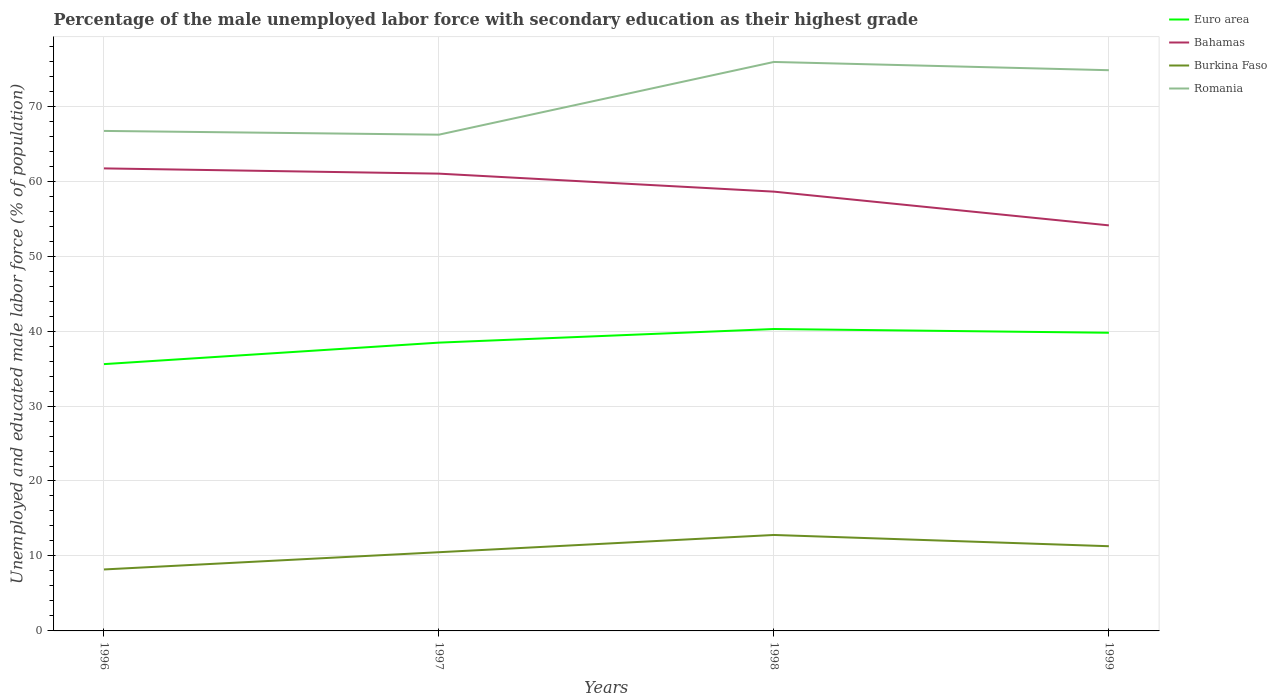Does the line corresponding to Bahamas intersect with the line corresponding to Burkina Faso?
Your answer should be very brief. No. Is the number of lines equal to the number of legend labels?
Your response must be concise. Yes. Across all years, what is the maximum percentage of the unemployed male labor force with secondary education in Romania?
Ensure brevity in your answer.  66.2. What is the total percentage of the unemployed male labor force with secondary education in Euro area in the graph?
Make the answer very short. -4.68. What is the difference between the highest and the second highest percentage of the unemployed male labor force with secondary education in Burkina Faso?
Your response must be concise. 4.6. How many years are there in the graph?
Give a very brief answer. 4. Are the values on the major ticks of Y-axis written in scientific E-notation?
Your response must be concise. No. Does the graph contain any zero values?
Provide a succinct answer. No. What is the title of the graph?
Give a very brief answer. Percentage of the male unemployed labor force with secondary education as their highest grade. Does "Indonesia" appear as one of the legend labels in the graph?
Give a very brief answer. No. What is the label or title of the X-axis?
Your answer should be very brief. Years. What is the label or title of the Y-axis?
Provide a succinct answer. Unemployed and educated male labor force (% of population). What is the Unemployed and educated male labor force (% of population) in Euro area in 1996?
Make the answer very short. 35.59. What is the Unemployed and educated male labor force (% of population) in Bahamas in 1996?
Keep it short and to the point. 61.7. What is the Unemployed and educated male labor force (% of population) in Burkina Faso in 1996?
Provide a short and direct response. 8.2. What is the Unemployed and educated male labor force (% of population) in Romania in 1996?
Your answer should be very brief. 66.7. What is the Unemployed and educated male labor force (% of population) in Euro area in 1997?
Provide a short and direct response. 38.46. What is the Unemployed and educated male labor force (% of population) in Bahamas in 1997?
Offer a very short reply. 61. What is the Unemployed and educated male labor force (% of population) in Burkina Faso in 1997?
Keep it short and to the point. 10.5. What is the Unemployed and educated male labor force (% of population) in Romania in 1997?
Offer a very short reply. 66.2. What is the Unemployed and educated male labor force (% of population) in Euro area in 1998?
Your answer should be very brief. 40.27. What is the Unemployed and educated male labor force (% of population) in Bahamas in 1998?
Provide a succinct answer. 58.6. What is the Unemployed and educated male labor force (% of population) in Burkina Faso in 1998?
Give a very brief answer. 12.8. What is the Unemployed and educated male labor force (% of population) of Romania in 1998?
Give a very brief answer. 75.9. What is the Unemployed and educated male labor force (% of population) of Euro area in 1999?
Make the answer very short. 39.78. What is the Unemployed and educated male labor force (% of population) of Bahamas in 1999?
Your response must be concise. 54.1. What is the Unemployed and educated male labor force (% of population) of Burkina Faso in 1999?
Keep it short and to the point. 11.3. What is the Unemployed and educated male labor force (% of population) in Romania in 1999?
Provide a succinct answer. 74.8. Across all years, what is the maximum Unemployed and educated male labor force (% of population) of Euro area?
Provide a short and direct response. 40.27. Across all years, what is the maximum Unemployed and educated male labor force (% of population) in Bahamas?
Give a very brief answer. 61.7. Across all years, what is the maximum Unemployed and educated male labor force (% of population) of Burkina Faso?
Provide a short and direct response. 12.8. Across all years, what is the maximum Unemployed and educated male labor force (% of population) of Romania?
Ensure brevity in your answer.  75.9. Across all years, what is the minimum Unemployed and educated male labor force (% of population) of Euro area?
Keep it short and to the point. 35.59. Across all years, what is the minimum Unemployed and educated male labor force (% of population) of Bahamas?
Provide a short and direct response. 54.1. Across all years, what is the minimum Unemployed and educated male labor force (% of population) in Burkina Faso?
Keep it short and to the point. 8.2. Across all years, what is the minimum Unemployed and educated male labor force (% of population) of Romania?
Keep it short and to the point. 66.2. What is the total Unemployed and educated male labor force (% of population) in Euro area in the graph?
Your answer should be compact. 154.1. What is the total Unemployed and educated male labor force (% of population) in Bahamas in the graph?
Offer a terse response. 235.4. What is the total Unemployed and educated male labor force (% of population) in Burkina Faso in the graph?
Offer a terse response. 42.8. What is the total Unemployed and educated male labor force (% of population) of Romania in the graph?
Offer a terse response. 283.6. What is the difference between the Unemployed and educated male labor force (% of population) of Euro area in 1996 and that in 1997?
Ensure brevity in your answer.  -2.87. What is the difference between the Unemployed and educated male labor force (% of population) of Bahamas in 1996 and that in 1997?
Offer a terse response. 0.7. What is the difference between the Unemployed and educated male labor force (% of population) in Romania in 1996 and that in 1997?
Your answer should be compact. 0.5. What is the difference between the Unemployed and educated male labor force (% of population) in Euro area in 1996 and that in 1998?
Keep it short and to the point. -4.68. What is the difference between the Unemployed and educated male labor force (% of population) in Bahamas in 1996 and that in 1998?
Your answer should be compact. 3.1. What is the difference between the Unemployed and educated male labor force (% of population) in Romania in 1996 and that in 1998?
Your answer should be very brief. -9.2. What is the difference between the Unemployed and educated male labor force (% of population) of Euro area in 1996 and that in 1999?
Ensure brevity in your answer.  -4.19. What is the difference between the Unemployed and educated male labor force (% of population) of Euro area in 1997 and that in 1998?
Your answer should be compact. -1.81. What is the difference between the Unemployed and educated male labor force (% of population) of Bahamas in 1997 and that in 1998?
Your response must be concise. 2.4. What is the difference between the Unemployed and educated male labor force (% of population) in Burkina Faso in 1997 and that in 1998?
Your response must be concise. -2.3. What is the difference between the Unemployed and educated male labor force (% of population) in Euro area in 1997 and that in 1999?
Give a very brief answer. -1.32. What is the difference between the Unemployed and educated male labor force (% of population) of Bahamas in 1997 and that in 1999?
Make the answer very short. 6.9. What is the difference between the Unemployed and educated male labor force (% of population) in Burkina Faso in 1997 and that in 1999?
Your response must be concise. -0.8. What is the difference between the Unemployed and educated male labor force (% of population) of Romania in 1997 and that in 1999?
Make the answer very short. -8.6. What is the difference between the Unemployed and educated male labor force (% of population) in Euro area in 1998 and that in 1999?
Offer a very short reply. 0.5. What is the difference between the Unemployed and educated male labor force (% of population) of Euro area in 1996 and the Unemployed and educated male labor force (% of population) of Bahamas in 1997?
Offer a terse response. -25.41. What is the difference between the Unemployed and educated male labor force (% of population) of Euro area in 1996 and the Unemployed and educated male labor force (% of population) of Burkina Faso in 1997?
Offer a very short reply. 25.09. What is the difference between the Unemployed and educated male labor force (% of population) of Euro area in 1996 and the Unemployed and educated male labor force (% of population) of Romania in 1997?
Offer a very short reply. -30.61. What is the difference between the Unemployed and educated male labor force (% of population) of Bahamas in 1996 and the Unemployed and educated male labor force (% of population) of Burkina Faso in 1997?
Provide a short and direct response. 51.2. What is the difference between the Unemployed and educated male labor force (% of population) of Burkina Faso in 1996 and the Unemployed and educated male labor force (% of population) of Romania in 1997?
Ensure brevity in your answer.  -58. What is the difference between the Unemployed and educated male labor force (% of population) in Euro area in 1996 and the Unemployed and educated male labor force (% of population) in Bahamas in 1998?
Your answer should be very brief. -23.01. What is the difference between the Unemployed and educated male labor force (% of population) in Euro area in 1996 and the Unemployed and educated male labor force (% of population) in Burkina Faso in 1998?
Your answer should be compact. 22.79. What is the difference between the Unemployed and educated male labor force (% of population) of Euro area in 1996 and the Unemployed and educated male labor force (% of population) of Romania in 1998?
Your answer should be compact. -40.31. What is the difference between the Unemployed and educated male labor force (% of population) of Bahamas in 1996 and the Unemployed and educated male labor force (% of population) of Burkina Faso in 1998?
Your answer should be compact. 48.9. What is the difference between the Unemployed and educated male labor force (% of population) of Burkina Faso in 1996 and the Unemployed and educated male labor force (% of population) of Romania in 1998?
Ensure brevity in your answer.  -67.7. What is the difference between the Unemployed and educated male labor force (% of population) in Euro area in 1996 and the Unemployed and educated male labor force (% of population) in Bahamas in 1999?
Your response must be concise. -18.51. What is the difference between the Unemployed and educated male labor force (% of population) in Euro area in 1996 and the Unemployed and educated male labor force (% of population) in Burkina Faso in 1999?
Keep it short and to the point. 24.29. What is the difference between the Unemployed and educated male labor force (% of population) of Euro area in 1996 and the Unemployed and educated male labor force (% of population) of Romania in 1999?
Your response must be concise. -39.21. What is the difference between the Unemployed and educated male labor force (% of population) of Bahamas in 1996 and the Unemployed and educated male labor force (% of population) of Burkina Faso in 1999?
Offer a terse response. 50.4. What is the difference between the Unemployed and educated male labor force (% of population) of Bahamas in 1996 and the Unemployed and educated male labor force (% of population) of Romania in 1999?
Offer a very short reply. -13.1. What is the difference between the Unemployed and educated male labor force (% of population) in Burkina Faso in 1996 and the Unemployed and educated male labor force (% of population) in Romania in 1999?
Keep it short and to the point. -66.6. What is the difference between the Unemployed and educated male labor force (% of population) of Euro area in 1997 and the Unemployed and educated male labor force (% of population) of Bahamas in 1998?
Provide a succinct answer. -20.14. What is the difference between the Unemployed and educated male labor force (% of population) of Euro area in 1997 and the Unemployed and educated male labor force (% of population) of Burkina Faso in 1998?
Make the answer very short. 25.66. What is the difference between the Unemployed and educated male labor force (% of population) in Euro area in 1997 and the Unemployed and educated male labor force (% of population) in Romania in 1998?
Ensure brevity in your answer.  -37.44. What is the difference between the Unemployed and educated male labor force (% of population) of Bahamas in 1997 and the Unemployed and educated male labor force (% of population) of Burkina Faso in 1998?
Provide a short and direct response. 48.2. What is the difference between the Unemployed and educated male labor force (% of population) in Bahamas in 1997 and the Unemployed and educated male labor force (% of population) in Romania in 1998?
Make the answer very short. -14.9. What is the difference between the Unemployed and educated male labor force (% of population) in Burkina Faso in 1997 and the Unemployed and educated male labor force (% of population) in Romania in 1998?
Your answer should be very brief. -65.4. What is the difference between the Unemployed and educated male labor force (% of population) of Euro area in 1997 and the Unemployed and educated male labor force (% of population) of Bahamas in 1999?
Provide a short and direct response. -15.64. What is the difference between the Unemployed and educated male labor force (% of population) in Euro area in 1997 and the Unemployed and educated male labor force (% of population) in Burkina Faso in 1999?
Keep it short and to the point. 27.16. What is the difference between the Unemployed and educated male labor force (% of population) in Euro area in 1997 and the Unemployed and educated male labor force (% of population) in Romania in 1999?
Your answer should be very brief. -36.34. What is the difference between the Unemployed and educated male labor force (% of population) in Bahamas in 1997 and the Unemployed and educated male labor force (% of population) in Burkina Faso in 1999?
Your response must be concise. 49.7. What is the difference between the Unemployed and educated male labor force (% of population) in Burkina Faso in 1997 and the Unemployed and educated male labor force (% of population) in Romania in 1999?
Make the answer very short. -64.3. What is the difference between the Unemployed and educated male labor force (% of population) of Euro area in 1998 and the Unemployed and educated male labor force (% of population) of Bahamas in 1999?
Your answer should be compact. -13.83. What is the difference between the Unemployed and educated male labor force (% of population) in Euro area in 1998 and the Unemployed and educated male labor force (% of population) in Burkina Faso in 1999?
Offer a very short reply. 28.97. What is the difference between the Unemployed and educated male labor force (% of population) of Euro area in 1998 and the Unemployed and educated male labor force (% of population) of Romania in 1999?
Your answer should be compact. -34.53. What is the difference between the Unemployed and educated male labor force (% of population) of Bahamas in 1998 and the Unemployed and educated male labor force (% of population) of Burkina Faso in 1999?
Provide a short and direct response. 47.3. What is the difference between the Unemployed and educated male labor force (% of population) in Bahamas in 1998 and the Unemployed and educated male labor force (% of population) in Romania in 1999?
Your answer should be compact. -16.2. What is the difference between the Unemployed and educated male labor force (% of population) of Burkina Faso in 1998 and the Unemployed and educated male labor force (% of population) of Romania in 1999?
Provide a succinct answer. -62. What is the average Unemployed and educated male labor force (% of population) in Euro area per year?
Provide a short and direct response. 38.52. What is the average Unemployed and educated male labor force (% of population) of Bahamas per year?
Keep it short and to the point. 58.85. What is the average Unemployed and educated male labor force (% of population) in Burkina Faso per year?
Ensure brevity in your answer.  10.7. What is the average Unemployed and educated male labor force (% of population) in Romania per year?
Make the answer very short. 70.9. In the year 1996, what is the difference between the Unemployed and educated male labor force (% of population) of Euro area and Unemployed and educated male labor force (% of population) of Bahamas?
Your answer should be compact. -26.11. In the year 1996, what is the difference between the Unemployed and educated male labor force (% of population) in Euro area and Unemployed and educated male labor force (% of population) in Burkina Faso?
Give a very brief answer. 27.39. In the year 1996, what is the difference between the Unemployed and educated male labor force (% of population) of Euro area and Unemployed and educated male labor force (% of population) of Romania?
Keep it short and to the point. -31.11. In the year 1996, what is the difference between the Unemployed and educated male labor force (% of population) of Bahamas and Unemployed and educated male labor force (% of population) of Burkina Faso?
Provide a succinct answer. 53.5. In the year 1996, what is the difference between the Unemployed and educated male labor force (% of population) in Burkina Faso and Unemployed and educated male labor force (% of population) in Romania?
Give a very brief answer. -58.5. In the year 1997, what is the difference between the Unemployed and educated male labor force (% of population) of Euro area and Unemployed and educated male labor force (% of population) of Bahamas?
Your answer should be very brief. -22.54. In the year 1997, what is the difference between the Unemployed and educated male labor force (% of population) in Euro area and Unemployed and educated male labor force (% of population) in Burkina Faso?
Your response must be concise. 27.96. In the year 1997, what is the difference between the Unemployed and educated male labor force (% of population) in Euro area and Unemployed and educated male labor force (% of population) in Romania?
Make the answer very short. -27.74. In the year 1997, what is the difference between the Unemployed and educated male labor force (% of population) in Bahamas and Unemployed and educated male labor force (% of population) in Burkina Faso?
Offer a terse response. 50.5. In the year 1997, what is the difference between the Unemployed and educated male labor force (% of population) of Burkina Faso and Unemployed and educated male labor force (% of population) of Romania?
Give a very brief answer. -55.7. In the year 1998, what is the difference between the Unemployed and educated male labor force (% of population) of Euro area and Unemployed and educated male labor force (% of population) of Bahamas?
Provide a short and direct response. -18.33. In the year 1998, what is the difference between the Unemployed and educated male labor force (% of population) in Euro area and Unemployed and educated male labor force (% of population) in Burkina Faso?
Offer a terse response. 27.47. In the year 1998, what is the difference between the Unemployed and educated male labor force (% of population) of Euro area and Unemployed and educated male labor force (% of population) of Romania?
Your response must be concise. -35.63. In the year 1998, what is the difference between the Unemployed and educated male labor force (% of population) of Bahamas and Unemployed and educated male labor force (% of population) of Burkina Faso?
Your answer should be compact. 45.8. In the year 1998, what is the difference between the Unemployed and educated male labor force (% of population) in Bahamas and Unemployed and educated male labor force (% of population) in Romania?
Keep it short and to the point. -17.3. In the year 1998, what is the difference between the Unemployed and educated male labor force (% of population) of Burkina Faso and Unemployed and educated male labor force (% of population) of Romania?
Offer a terse response. -63.1. In the year 1999, what is the difference between the Unemployed and educated male labor force (% of population) of Euro area and Unemployed and educated male labor force (% of population) of Bahamas?
Give a very brief answer. -14.32. In the year 1999, what is the difference between the Unemployed and educated male labor force (% of population) in Euro area and Unemployed and educated male labor force (% of population) in Burkina Faso?
Offer a very short reply. 28.48. In the year 1999, what is the difference between the Unemployed and educated male labor force (% of population) of Euro area and Unemployed and educated male labor force (% of population) of Romania?
Make the answer very short. -35.02. In the year 1999, what is the difference between the Unemployed and educated male labor force (% of population) of Bahamas and Unemployed and educated male labor force (% of population) of Burkina Faso?
Make the answer very short. 42.8. In the year 1999, what is the difference between the Unemployed and educated male labor force (% of population) of Bahamas and Unemployed and educated male labor force (% of population) of Romania?
Offer a terse response. -20.7. In the year 1999, what is the difference between the Unemployed and educated male labor force (% of population) of Burkina Faso and Unemployed and educated male labor force (% of population) of Romania?
Offer a very short reply. -63.5. What is the ratio of the Unemployed and educated male labor force (% of population) of Euro area in 1996 to that in 1997?
Offer a very short reply. 0.93. What is the ratio of the Unemployed and educated male labor force (% of population) of Bahamas in 1996 to that in 1997?
Provide a short and direct response. 1.01. What is the ratio of the Unemployed and educated male labor force (% of population) in Burkina Faso in 1996 to that in 1997?
Make the answer very short. 0.78. What is the ratio of the Unemployed and educated male labor force (% of population) of Romania in 1996 to that in 1997?
Provide a succinct answer. 1.01. What is the ratio of the Unemployed and educated male labor force (% of population) in Euro area in 1996 to that in 1998?
Provide a short and direct response. 0.88. What is the ratio of the Unemployed and educated male labor force (% of population) of Bahamas in 1996 to that in 1998?
Give a very brief answer. 1.05. What is the ratio of the Unemployed and educated male labor force (% of population) of Burkina Faso in 1996 to that in 1998?
Give a very brief answer. 0.64. What is the ratio of the Unemployed and educated male labor force (% of population) of Romania in 1996 to that in 1998?
Make the answer very short. 0.88. What is the ratio of the Unemployed and educated male labor force (% of population) of Euro area in 1996 to that in 1999?
Your answer should be compact. 0.89. What is the ratio of the Unemployed and educated male labor force (% of population) in Bahamas in 1996 to that in 1999?
Give a very brief answer. 1.14. What is the ratio of the Unemployed and educated male labor force (% of population) of Burkina Faso in 1996 to that in 1999?
Keep it short and to the point. 0.73. What is the ratio of the Unemployed and educated male labor force (% of population) of Romania in 1996 to that in 1999?
Keep it short and to the point. 0.89. What is the ratio of the Unemployed and educated male labor force (% of population) in Euro area in 1997 to that in 1998?
Keep it short and to the point. 0.95. What is the ratio of the Unemployed and educated male labor force (% of population) in Bahamas in 1997 to that in 1998?
Ensure brevity in your answer.  1.04. What is the ratio of the Unemployed and educated male labor force (% of population) in Burkina Faso in 1997 to that in 1998?
Make the answer very short. 0.82. What is the ratio of the Unemployed and educated male labor force (% of population) in Romania in 1997 to that in 1998?
Your response must be concise. 0.87. What is the ratio of the Unemployed and educated male labor force (% of population) in Euro area in 1997 to that in 1999?
Keep it short and to the point. 0.97. What is the ratio of the Unemployed and educated male labor force (% of population) in Bahamas in 1997 to that in 1999?
Your answer should be very brief. 1.13. What is the ratio of the Unemployed and educated male labor force (% of population) of Burkina Faso in 1997 to that in 1999?
Make the answer very short. 0.93. What is the ratio of the Unemployed and educated male labor force (% of population) in Romania in 1997 to that in 1999?
Keep it short and to the point. 0.89. What is the ratio of the Unemployed and educated male labor force (% of population) of Euro area in 1998 to that in 1999?
Your response must be concise. 1.01. What is the ratio of the Unemployed and educated male labor force (% of population) of Bahamas in 1998 to that in 1999?
Keep it short and to the point. 1.08. What is the ratio of the Unemployed and educated male labor force (% of population) of Burkina Faso in 1998 to that in 1999?
Offer a very short reply. 1.13. What is the ratio of the Unemployed and educated male labor force (% of population) in Romania in 1998 to that in 1999?
Your answer should be compact. 1.01. What is the difference between the highest and the second highest Unemployed and educated male labor force (% of population) of Euro area?
Your response must be concise. 0.5. What is the difference between the highest and the second highest Unemployed and educated male labor force (% of population) of Burkina Faso?
Offer a very short reply. 1.5. What is the difference between the highest and the lowest Unemployed and educated male labor force (% of population) of Euro area?
Keep it short and to the point. 4.68. What is the difference between the highest and the lowest Unemployed and educated male labor force (% of population) of Bahamas?
Your answer should be compact. 7.6. What is the difference between the highest and the lowest Unemployed and educated male labor force (% of population) in Burkina Faso?
Ensure brevity in your answer.  4.6. 